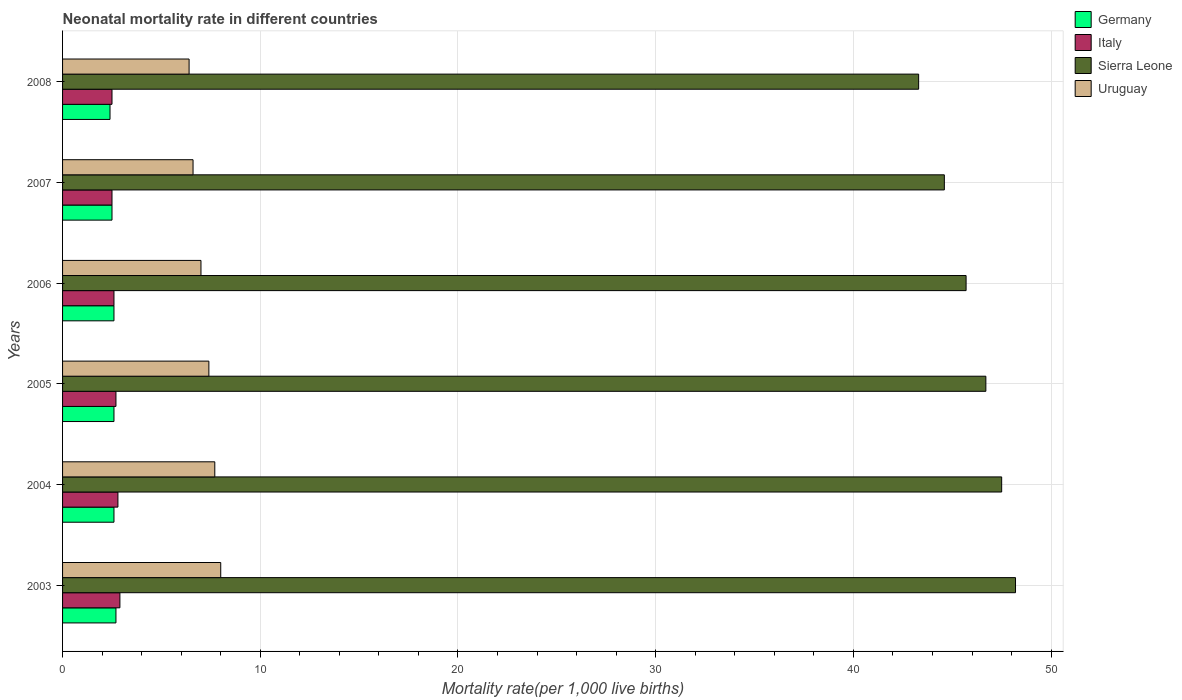How many groups of bars are there?
Your response must be concise. 6. How many bars are there on the 3rd tick from the bottom?
Provide a short and direct response. 4. What is the neonatal mortality rate in Italy in 2008?
Make the answer very short. 2.5. Across all years, what is the maximum neonatal mortality rate in Sierra Leone?
Offer a terse response. 48.2. Across all years, what is the minimum neonatal mortality rate in Uruguay?
Your response must be concise. 6.4. In which year was the neonatal mortality rate in Germany minimum?
Ensure brevity in your answer.  2008. What is the total neonatal mortality rate in Uruguay in the graph?
Your response must be concise. 43.1. What is the difference between the neonatal mortality rate in Italy in 2004 and that in 2005?
Keep it short and to the point. 0.1. What is the average neonatal mortality rate in Germany per year?
Give a very brief answer. 2.57. In the year 2007, what is the difference between the neonatal mortality rate in Germany and neonatal mortality rate in Italy?
Your answer should be very brief. 0. What is the ratio of the neonatal mortality rate in Germany in 2005 to that in 2006?
Your response must be concise. 1. What is the difference between the highest and the second highest neonatal mortality rate in Uruguay?
Make the answer very short. 0.3. What is the difference between the highest and the lowest neonatal mortality rate in Italy?
Offer a terse response. 0.4. In how many years, is the neonatal mortality rate in Sierra Leone greater than the average neonatal mortality rate in Sierra Leone taken over all years?
Provide a short and direct response. 3. What does the 4th bar from the bottom in 2003 represents?
Ensure brevity in your answer.  Uruguay. How many bars are there?
Give a very brief answer. 24. Does the graph contain grids?
Give a very brief answer. Yes. What is the title of the graph?
Offer a terse response. Neonatal mortality rate in different countries. Does "Comoros" appear as one of the legend labels in the graph?
Ensure brevity in your answer.  No. What is the label or title of the X-axis?
Your answer should be compact. Mortality rate(per 1,0 live births). What is the label or title of the Y-axis?
Your answer should be compact. Years. What is the Mortality rate(per 1,000 live births) of Sierra Leone in 2003?
Your answer should be very brief. 48.2. What is the Mortality rate(per 1,000 live births) of Uruguay in 2003?
Offer a very short reply. 8. What is the Mortality rate(per 1,000 live births) of Germany in 2004?
Make the answer very short. 2.6. What is the Mortality rate(per 1,000 live births) of Sierra Leone in 2004?
Make the answer very short. 47.5. What is the Mortality rate(per 1,000 live births) in Sierra Leone in 2005?
Ensure brevity in your answer.  46.7. What is the Mortality rate(per 1,000 live births) in Uruguay in 2005?
Offer a very short reply. 7.4. What is the Mortality rate(per 1,000 live births) of Germany in 2006?
Provide a short and direct response. 2.6. What is the Mortality rate(per 1,000 live births) of Italy in 2006?
Provide a succinct answer. 2.6. What is the Mortality rate(per 1,000 live births) of Sierra Leone in 2006?
Ensure brevity in your answer.  45.7. What is the Mortality rate(per 1,000 live births) of Italy in 2007?
Keep it short and to the point. 2.5. What is the Mortality rate(per 1,000 live births) in Sierra Leone in 2007?
Keep it short and to the point. 44.6. What is the Mortality rate(per 1,000 live births) in Uruguay in 2007?
Offer a terse response. 6.6. What is the Mortality rate(per 1,000 live births) of Germany in 2008?
Offer a very short reply. 2.4. What is the Mortality rate(per 1,000 live births) of Sierra Leone in 2008?
Provide a succinct answer. 43.3. Across all years, what is the maximum Mortality rate(per 1,000 live births) in Germany?
Keep it short and to the point. 2.7. Across all years, what is the maximum Mortality rate(per 1,000 live births) in Sierra Leone?
Your response must be concise. 48.2. Across all years, what is the minimum Mortality rate(per 1,000 live births) of Sierra Leone?
Offer a very short reply. 43.3. What is the total Mortality rate(per 1,000 live births) in Germany in the graph?
Your answer should be very brief. 15.4. What is the total Mortality rate(per 1,000 live births) of Sierra Leone in the graph?
Ensure brevity in your answer.  276. What is the total Mortality rate(per 1,000 live births) in Uruguay in the graph?
Provide a succinct answer. 43.1. What is the difference between the Mortality rate(per 1,000 live births) of Germany in 2003 and that in 2004?
Your response must be concise. 0.1. What is the difference between the Mortality rate(per 1,000 live births) of Italy in 2003 and that in 2004?
Your response must be concise. 0.1. What is the difference between the Mortality rate(per 1,000 live births) of Sierra Leone in 2003 and that in 2004?
Offer a very short reply. 0.7. What is the difference between the Mortality rate(per 1,000 live births) in Italy in 2003 and that in 2005?
Your answer should be very brief. 0.2. What is the difference between the Mortality rate(per 1,000 live births) in Uruguay in 2003 and that in 2005?
Give a very brief answer. 0.6. What is the difference between the Mortality rate(per 1,000 live births) in Germany in 2003 and that in 2006?
Offer a very short reply. 0.1. What is the difference between the Mortality rate(per 1,000 live births) of Italy in 2003 and that in 2006?
Offer a very short reply. 0.3. What is the difference between the Mortality rate(per 1,000 live births) of Sierra Leone in 2003 and that in 2006?
Offer a terse response. 2.5. What is the difference between the Mortality rate(per 1,000 live births) of Germany in 2003 and that in 2007?
Give a very brief answer. 0.2. What is the difference between the Mortality rate(per 1,000 live births) in Uruguay in 2003 and that in 2007?
Ensure brevity in your answer.  1.4. What is the difference between the Mortality rate(per 1,000 live births) in Germany in 2003 and that in 2008?
Make the answer very short. 0.3. What is the difference between the Mortality rate(per 1,000 live births) in Italy in 2003 and that in 2008?
Your answer should be compact. 0.4. What is the difference between the Mortality rate(per 1,000 live births) in Germany in 2004 and that in 2005?
Give a very brief answer. 0. What is the difference between the Mortality rate(per 1,000 live births) in Sierra Leone in 2004 and that in 2005?
Offer a very short reply. 0.8. What is the difference between the Mortality rate(per 1,000 live births) of Germany in 2004 and that in 2006?
Provide a succinct answer. 0. What is the difference between the Mortality rate(per 1,000 live births) in Uruguay in 2004 and that in 2006?
Your answer should be compact. 0.7. What is the difference between the Mortality rate(per 1,000 live births) in Sierra Leone in 2004 and that in 2007?
Ensure brevity in your answer.  2.9. What is the difference between the Mortality rate(per 1,000 live births) of Italy in 2004 and that in 2008?
Make the answer very short. 0.3. What is the difference between the Mortality rate(per 1,000 live births) in Italy in 2005 and that in 2006?
Ensure brevity in your answer.  0.1. What is the difference between the Mortality rate(per 1,000 live births) of Italy in 2005 and that in 2007?
Offer a very short reply. 0.2. What is the difference between the Mortality rate(per 1,000 live births) of Sierra Leone in 2005 and that in 2008?
Your response must be concise. 3.4. What is the difference between the Mortality rate(per 1,000 live births) in Italy in 2006 and that in 2007?
Your response must be concise. 0.1. What is the difference between the Mortality rate(per 1,000 live births) in Sierra Leone in 2006 and that in 2007?
Offer a terse response. 1.1. What is the difference between the Mortality rate(per 1,000 live births) of Germany in 2006 and that in 2008?
Keep it short and to the point. 0.2. What is the difference between the Mortality rate(per 1,000 live births) in Italy in 2006 and that in 2008?
Ensure brevity in your answer.  0.1. What is the difference between the Mortality rate(per 1,000 live births) of Uruguay in 2006 and that in 2008?
Keep it short and to the point. 0.6. What is the difference between the Mortality rate(per 1,000 live births) in Germany in 2003 and the Mortality rate(per 1,000 live births) in Italy in 2004?
Provide a succinct answer. -0.1. What is the difference between the Mortality rate(per 1,000 live births) in Germany in 2003 and the Mortality rate(per 1,000 live births) in Sierra Leone in 2004?
Offer a very short reply. -44.8. What is the difference between the Mortality rate(per 1,000 live births) of Germany in 2003 and the Mortality rate(per 1,000 live births) of Uruguay in 2004?
Make the answer very short. -5. What is the difference between the Mortality rate(per 1,000 live births) of Italy in 2003 and the Mortality rate(per 1,000 live births) of Sierra Leone in 2004?
Your answer should be compact. -44.6. What is the difference between the Mortality rate(per 1,000 live births) of Italy in 2003 and the Mortality rate(per 1,000 live births) of Uruguay in 2004?
Offer a terse response. -4.8. What is the difference between the Mortality rate(per 1,000 live births) of Sierra Leone in 2003 and the Mortality rate(per 1,000 live births) of Uruguay in 2004?
Keep it short and to the point. 40.5. What is the difference between the Mortality rate(per 1,000 live births) in Germany in 2003 and the Mortality rate(per 1,000 live births) in Italy in 2005?
Provide a succinct answer. 0. What is the difference between the Mortality rate(per 1,000 live births) of Germany in 2003 and the Mortality rate(per 1,000 live births) of Sierra Leone in 2005?
Make the answer very short. -44. What is the difference between the Mortality rate(per 1,000 live births) of Germany in 2003 and the Mortality rate(per 1,000 live births) of Uruguay in 2005?
Keep it short and to the point. -4.7. What is the difference between the Mortality rate(per 1,000 live births) of Italy in 2003 and the Mortality rate(per 1,000 live births) of Sierra Leone in 2005?
Ensure brevity in your answer.  -43.8. What is the difference between the Mortality rate(per 1,000 live births) in Italy in 2003 and the Mortality rate(per 1,000 live births) in Uruguay in 2005?
Offer a terse response. -4.5. What is the difference between the Mortality rate(per 1,000 live births) of Sierra Leone in 2003 and the Mortality rate(per 1,000 live births) of Uruguay in 2005?
Give a very brief answer. 40.8. What is the difference between the Mortality rate(per 1,000 live births) of Germany in 2003 and the Mortality rate(per 1,000 live births) of Sierra Leone in 2006?
Your response must be concise. -43. What is the difference between the Mortality rate(per 1,000 live births) of Italy in 2003 and the Mortality rate(per 1,000 live births) of Sierra Leone in 2006?
Keep it short and to the point. -42.8. What is the difference between the Mortality rate(per 1,000 live births) of Sierra Leone in 2003 and the Mortality rate(per 1,000 live births) of Uruguay in 2006?
Provide a succinct answer. 41.2. What is the difference between the Mortality rate(per 1,000 live births) in Germany in 2003 and the Mortality rate(per 1,000 live births) in Italy in 2007?
Your answer should be very brief. 0.2. What is the difference between the Mortality rate(per 1,000 live births) in Germany in 2003 and the Mortality rate(per 1,000 live births) in Sierra Leone in 2007?
Provide a succinct answer. -41.9. What is the difference between the Mortality rate(per 1,000 live births) of Germany in 2003 and the Mortality rate(per 1,000 live births) of Uruguay in 2007?
Ensure brevity in your answer.  -3.9. What is the difference between the Mortality rate(per 1,000 live births) of Italy in 2003 and the Mortality rate(per 1,000 live births) of Sierra Leone in 2007?
Provide a short and direct response. -41.7. What is the difference between the Mortality rate(per 1,000 live births) of Sierra Leone in 2003 and the Mortality rate(per 1,000 live births) of Uruguay in 2007?
Offer a terse response. 41.6. What is the difference between the Mortality rate(per 1,000 live births) in Germany in 2003 and the Mortality rate(per 1,000 live births) in Italy in 2008?
Your answer should be very brief. 0.2. What is the difference between the Mortality rate(per 1,000 live births) of Germany in 2003 and the Mortality rate(per 1,000 live births) of Sierra Leone in 2008?
Give a very brief answer. -40.6. What is the difference between the Mortality rate(per 1,000 live births) in Germany in 2003 and the Mortality rate(per 1,000 live births) in Uruguay in 2008?
Your answer should be very brief. -3.7. What is the difference between the Mortality rate(per 1,000 live births) in Italy in 2003 and the Mortality rate(per 1,000 live births) in Sierra Leone in 2008?
Offer a terse response. -40.4. What is the difference between the Mortality rate(per 1,000 live births) of Sierra Leone in 2003 and the Mortality rate(per 1,000 live births) of Uruguay in 2008?
Make the answer very short. 41.8. What is the difference between the Mortality rate(per 1,000 live births) in Germany in 2004 and the Mortality rate(per 1,000 live births) in Italy in 2005?
Provide a succinct answer. -0.1. What is the difference between the Mortality rate(per 1,000 live births) in Germany in 2004 and the Mortality rate(per 1,000 live births) in Sierra Leone in 2005?
Offer a very short reply. -44.1. What is the difference between the Mortality rate(per 1,000 live births) in Germany in 2004 and the Mortality rate(per 1,000 live births) in Uruguay in 2005?
Keep it short and to the point. -4.8. What is the difference between the Mortality rate(per 1,000 live births) in Italy in 2004 and the Mortality rate(per 1,000 live births) in Sierra Leone in 2005?
Provide a short and direct response. -43.9. What is the difference between the Mortality rate(per 1,000 live births) of Sierra Leone in 2004 and the Mortality rate(per 1,000 live births) of Uruguay in 2005?
Give a very brief answer. 40.1. What is the difference between the Mortality rate(per 1,000 live births) in Germany in 2004 and the Mortality rate(per 1,000 live births) in Sierra Leone in 2006?
Provide a short and direct response. -43.1. What is the difference between the Mortality rate(per 1,000 live births) of Germany in 2004 and the Mortality rate(per 1,000 live births) of Uruguay in 2006?
Offer a terse response. -4.4. What is the difference between the Mortality rate(per 1,000 live births) in Italy in 2004 and the Mortality rate(per 1,000 live births) in Sierra Leone in 2006?
Offer a very short reply. -42.9. What is the difference between the Mortality rate(per 1,000 live births) of Sierra Leone in 2004 and the Mortality rate(per 1,000 live births) of Uruguay in 2006?
Provide a succinct answer. 40.5. What is the difference between the Mortality rate(per 1,000 live births) of Germany in 2004 and the Mortality rate(per 1,000 live births) of Italy in 2007?
Your answer should be compact. 0.1. What is the difference between the Mortality rate(per 1,000 live births) of Germany in 2004 and the Mortality rate(per 1,000 live births) of Sierra Leone in 2007?
Keep it short and to the point. -42. What is the difference between the Mortality rate(per 1,000 live births) of Germany in 2004 and the Mortality rate(per 1,000 live births) of Uruguay in 2007?
Give a very brief answer. -4. What is the difference between the Mortality rate(per 1,000 live births) of Italy in 2004 and the Mortality rate(per 1,000 live births) of Sierra Leone in 2007?
Keep it short and to the point. -41.8. What is the difference between the Mortality rate(per 1,000 live births) of Sierra Leone in 2004 and the Mortality rate(per 1,000 live births) of Uruguay in 2007?
Your response must be concise. 40.9. What is the difference between the Mortality rate(per 1,000 live births) of Germany in 2004 and the Mortality rate(per 1,000 live births) of Italy in 2008?
Make the answer very short. 0.1. What is the difference between the Mortality rate(per 1,000 live births) of Germany in 2004 and the Mortality rate(per 1,000 live births) of Sierra Leone in 2008?
Keep it short and to the point. -40.7. What is the difference between the Mortality rate(per 1,000 live births) of Germany in 2004 and the Mortality rate(per 1,000 live births) of Uruguay in 2008?
Provide a short and direct response. -3.8. What is the difference between the Mortality rate(per 1,000 live births) in Italy in 2004 and the Mortality rate(per 1,000 live births) in Sierra Leone in 2008?
Provide a short and direct response. -40.5. What is the difference between the Mortality rate(per 1,000 live births) of Italy in 2004 and the Mortality rate(per 1,000 live births) of Uruguay in 2008?
Offer a very short reply. -3.6. What is the difference between the Mortality rate(per 1,000 live births) of Sierra Leone in 2004 and the Mortality rate(per 1,000 live births) of Uruguay in 2008?
Offer a terse response. 41.1. What is the difference between the Mortality rate(per 1,000 live births) in Germany in 2005 and the Mortality rate(per 1,000 live births) in Sierra Leone in 2006?
Provide a succinct answer. -43.1. What is the difference between the Mortality rate(per 1,000 live births) in Italy in 2005 and the Mortality rate(per 1,000 live births) in Sierra Leone in 2006?
Your response must be concise. -43. What is the difference between the Mortality rate(per 1,000 live births) in Italy in 2005 and the Mortality rate(per 1,000 live births) in Uruguay in 2006?
Keep it short and to the point. -4.3. What is the difference between the Mortality rate(per 1,000 live births) in Sierra Leone in 2005 and the Mortality rate(per 1,000 live births) in Uruguay in 2006?
Your answer should be very brief. 39.7. What is the difference between the Mortality rate(per 1,000 live births) of Germany in 2005 and the Mortality rate(per 1,000 live births) of Italy in 2007?
Give a very brief answer. 0.1. What is the difference between the Mortality rate(per 1,000 live births) of Germany in 2005 and the Mortality rate(per 1,000 live births) of Sierra Leone in 2007?
Offer a very short reply. -42. What is the difference between the Mortality rate(per 1,000 live births) in Italy in 2005 and the Mortality rate(per 1,000 live births) in Sierra Leone in 2007?
Ensure brevity in your answer.  -41.9. What is the difference between the Mortality rate(per 1,000 live births) of Sierra Leone in 2005 and the Mortality rate(per 1,000 live births) of Uruguay in 2007?
Your answer should be very brief. 40.1. What is the difference between the Mortality rate(per 1,000 live births) in Germany in 2005 and the Mortality rate(per 1,000 live births) in Italy in 2008?
Your answer should be compact. 0.1. What is the difference between the Mortality rate(per 1,000 live births) of Germany in 2005 and the Mortality rate(per 1,000 live births) of Sierra Leone in 2008?
Keep it short and to the point. -40.7. What is the difference between the Mortality rate(per 1,000 live births) of Germany in 2005 and the Mortality rate(per 1,000 live births) of Uruguay in 2008?
Keep it short and to the point. -3.8. What is the difference between the Mortality rate(per 1,000 live births) in Italy in 2005 and the Mortality rate(per 1,000 live births) in Sierra Leone in 2008?
Your answer should be very brief. -40.6. What is the difference between the Mortality rate(per 1,000 live births) in Italy in 2005 and the Mortality rate(per 1,000 live births) in Uruguay in 2008?
Offer a very short reply. -3.7. What is the difference between the Mortality rate(per 1,000 live births) of Sierra Leone in 2005 and the Mortality rate(per 1,000 live births) of Uruguay in 2008?
Offer a very short reply. 40.3. What is the difference between the Mortality rate(per 1,000 live births) of Germany in 2006 and the Mortality rate(per 1,000 live births) of Sierra Leone in 2007?
Give a very brief answer. -42. What is the difference between the Mortality rate(per 1,000 live births) of Germany in 2006 and the Mortality rate(per 1,000 live births) of Uruguay in 2007?
Give a very brief answer. -4. What is the difference between the Mortality rate(per 1,000 live births) in Italy in 2006 and the Mortality rate(per 1,000 live births) in Sierra Leone in 2007?
Ensure brevity in your answer.  -42. What is the difference between the Mortality rate(per 1,000 live births) in Italy in 2006 and the Mortality rate(per 1,000 live births) in Uruguay in 2007?
Provide a succinct answer. -4. What is the difference between the Mortality rate(per 1,000 live births) of Sierra Leone in 2006 and the Mortality rate(per 1,000 live births) of Uruguay in 2007?
Your answer should be compact. 39.1. What is the difference between the Mortality rate(per 1,000 live births) in Germany in 2006 and the Mortality rate(per 1,000 live births) in Sierra Leone in 2008?
Your response must be concise. -40.7. What is the difference between the Mortality rate(per 1,000 live births) of Italy in 2006 and the Mortality rate(per 1,000 live births) of Sierra Leone in 2008?
Ensure brevity in your answer.  -40.7. What is the difference between the Mortality rate(per 1,000 live births) in Sierra Leone in 2006 and the Mortality rate(per 1,000 live births) in Uruguay in 2008?
Your answer should be very brief. 39.3. What is the difference between the Mortality rate(per 1,000 live births) in Germany in 2007 and the Mortality rate(per 1,000 live births) in Sierra Leone in 2008?
Provide a short and direct response. -40.8. What is the difference between the Mortality rate(per 1,000 live births) of Germany in 2007 and the Mortality rate(per 1,000 live births) of Uruguay in 2008?
Offer a terse response. -3.9. What is the difference between the Mortality rate(per 1,000 live births) in Italy in 2007 and the Mortality rate(per 1,000 live births) in Sierra Leone in 2008?
Offer a very short reply. -40.8. What is the difference between the Mortality rate(per 1,000 live births) in Sierra Leone in 2007 and the Mortality rate(per 1,000 live births) in Uruguay in 2008?
Offer a very short reply. 38.2. What is the average Mortality rate(per 1,000 live births) in Germany per year?
Provide a short and direct response. 2.57. What is the average Mortality rate(per 1,000 live births) in Italy per year?
Your response must be concise. 2.67. What is the average Mortality rate(per 1,000 live births) of Uruguay per year?
Keep it short and to the point. 7.18. In the year 2003, what is the difference between the Mortality rate(per 1,000 live births) of Germany and Mortality rate(per 1,000 live births) of Sierra Leone?
Your response must be concise. -45.5. In the year 2003, what is the difference between the Mortality rate(per 1,000 live births) in Italy and Mortality rate(per 1,000 live births) in Sierra Leone?
Ensure brevity in your answer.  -45.3. In the year 2003, what is the difference between the Mortality rate(per 1,000 live births) in Italy and Mortality rate(per 1,000 live births) in Uruguay?
Your answer should be very brief. -5.1. In the year 2003, what is the difference between the Mortality rate(per 1,000 live births) of Sierra Leone and Mortality rate(per 1,000 live births) of Uruguay?
Your answer should be compact. 40.2. In the year 2004, what is the difference between the Mortality rate(per 1,000 live births) of Germany and Mortality rate(per 1,000 live births) of Italy?
Your answer should be compact. -0.2. In the year 2004, what is the difference between the Mortality rate(per 1,000 live births) of Germany and Mortality rate(per 1,000 live births) of Sierra Leone?
Provide a short and direct response. -44.9. In the year 2004, what is the difference between the Mortality rate(per 1,000 live births) in Germany and Mortality rate(per 1,000 live births) in Uruguay?
Offer a very short reply. -5.1. In the year 2004, what is the difference between the Mortality rate(per 1,000 live births) in Italy and Mortality rate(per 1,000 live births) in Sierra Leone?
Provide a succinct answer. -44.7. In the year 2004, what is the difference between the Mortality rate(per 1,000 live births) of Sierra Leone and Mortality rate(per 1,000 live births) of Uruguay?
Your response must be concise. 39.8. In the year 2005, what is the difference between the Mortality rate(per 1,000 live births) in Germany and Mortality rate(per 1,000 live births) in Italy?
Your answer should be very brief. -0.1. In the year 2005, what is the difference between the Mortality rate(per 1,000 live births) of Germany and Mortality rate(per 1,000 live births) of Sierra Leone?
Make the answer very short. -44.1. In the year 2005, what is the difference between the Mortality rate(per 1,000 live births) of Italy and Mortality rate(per 1,000 live births) of Sierra Leone?
Offer a terse response. -44. In the year 2005, what is the difference between the Mortality rate(per 1,000 live births) of Sierra Leone and Mortality rate(per 1,000 live births) of Uruguay?
Your answer should be very brief. 39.3. In the year 2006, what is the difference between the Mortality rate(per 1,000 live births) of Germany and Mortality rate(per 1,000 live births) of Sierra Leone?
Provide a succinct answer. -43.1. In the year 2006, what is the difference between the Mortality rate(per 1,000 live births) of Italy and Mortality rate(per 1,000 live births) of Sierra Leone?
Your answer should be very brief. -43.1. In the year 2006, what is the difference between the Mortality rate(per 1,000 live births) of Sierra Leone and Mortality rate(per 1,000 live births) of Uruguay?
Provide a short and direct response. 38.7. In the year 2007, what is the difference between the Mortality rate(per 1,000 live births) in Germany and Mortality rate(per 1,000 live births) in Italy?
Ensure brevity in your answer.  0. In the year 2007, what is the difference between the Mortality rate(per 1,000 live births) of Germany and Mortality rate(per 1,000 live births) of Sierra Leone?
Make the answer very short. -42.1. In the year 2007, what is the difference between the Mortality rate(per 1,000 live births) of Italy and Mortality rate(per 1,000 live births) of Sierra Leone?
Keep it short and to the point. -42.1. In the year 2007, what is the difference between the Mortality rate(per 1,000 live births) in Italy and Mortality rate(per 1,000 live births) in Uruguay?
Offer a very short reply. -4.1. In the year 2008, what is the difference between the Mortality rate(per 1,000 live births) of Germany and Mortality rate(per 1,000 live births) of Sierra Leone?
Make the answer very short. -40.9. In the year 2008, what is the difference between the Mortality rate(per 1,000 live births) in Italy and Mortality rate(per 1,000 live births) in Sierra Leone?
Offer a very short reply. -40.8. In the year 2008, what is the difference between the Mortality rate(per 1,000 live births) of Sierra Leone and Mortality rate(per 1,000 live births) of Uruguay?
Offer a terse response. 36.9. What is the ratio of the Mortality rate(per 1,000 live births) in Italy in 2003 to that in 2004?
Ensure brevity in your answer.  1.04. What is the ratio of the Mortality rate(per 1,000 live births) of Sierra Leone in 2003 to that in 2004?
Make the answer very short. 1.01. What is the ratio of the Mortality rate(per 1,000 live births) in Uruguay in 2003 to that in 2004?
Offer a very short reply. 1.04. What is the ratio of the Mortality rate(per 1,000 live births) of Germany in 2003 to that in 2005?
Keep it short and to the point. 1.04. What is the ratio of the Mortality rate(per 1,000 live births) in Italy in 2003 to that in 2005?
Ensure brevity in your answer.  1.07. What is the ratio of the Mortality rate(per 1,000 live births) in Sierra Leone in 2003 to that in 2005?
Offer a terse response. 1.03. What is the ratio of the Mortality rate(per 1,000 live births) in Uruguay in 2003 to that in 2005?
Ensure brevity in your answer.  1.08. What is the ratio of the Mortality rate(per 1,000 live births) in Italy in 2003 to that in 2006?
Offer a very short reply. 1.12. What is the ratio of the Mortality rate(per 1,000 live births) in Sierra Leone in 2003 to that in 2006?
Offer a terse response. 1.05. What is the ratio of the Mortality rate(per 1,000 live births) in Germany in 2003 to that in 2007?
Keep it short and to the point. 1.08. What is the ratio of the Mortality rate(per 1,000 live births) in Italy in 2003 to that in 2007?
Ensure brevity in your answer.  1.16. What is the ratio of the Mortality rate(per 1,000 live births) of Sierra Leone in 2003 to that in 2007?
Your answer should be very brief. 1.08. What is the ratio of the Mortality rate(per 1,000 live births) of Uruguay in 2003 to that in 2007?
Provide a succinct answer. 1.21. What is the ratio of the Mortality rate(per 1,000 live births) of Italy in 2003 to that in 2008?
Your answer should be compact. 1.16. What is the ratio of the Mortality rate(per 1,000 live births) of Sierra Leone in 2003 to that in 2008?
Offer a very short reply. 1.11. What is the ratio of the Mortality rate(per 1,000 live births) of Uruguay in 2003 to that in 2008?
Offer a very short reply. 1.25. What is the ratio of the Mortality rate(per 1,000 live births) of Sierra Leone in 2004 to that in 2005?
Provide a succinct answer. 1.02. What is the ratio of the Mortality rate(per 1,000 live births) in Uruguay in 2004 to that in 2005?
Keep it short and to the point. 1.04. What is the ratio of the Mortality rate(per 1,000 live births) in Germany in 2004 to that in 2006?
Make the answer very short. 1. What is the ratio of the Mortality rate(per 1,000 live births) in Sierra Leone in 2004 to that in 2006?
Offer a very short reply. 1.04. What is the ratio of the Mortality rate(per 1,000 live births) of Italy in 2004 to that in 2007?
Provide a short and direct response. 1.12. What is the ratio of the Mortality rate(per 1,000 live births) of Sierra Leone in 2004 to that in 2007?
Make the answer very short. 1.06. What is the ratio of the Mortality rate(per 1,000 live births) in Uruguay in 2004 to that in 2007?
Your response must be concise. 1.17. What is the ratio of the Mortality rate(per 1,000 live births) in Germany in 2004 to that in 2008?
Ensure brevity in your answer.  1.08. What is the ratio of the Mortality rate(per 1,000 live births) in Italy in 2004 to that in 2008?
Offer a terse response. 1.12. What is the ratio of the Mortality rate(per 1,000 live births) in Sierra Leone in 2004 to that in 2008?
Your response must be concise. 1.1. What is the ratio of the Mortality rate(per 1,000 live births) of Uruguay in 2004 to that in 2008?
Ensure brevity in your answer.  1.2. What is the ratio of the Mortality rate(per 1,000 live births) of Sierra Leone in 2005 to that in 2006?
Keep it short and to the point. 1.02. What is the ratio of the Mortality rate(per 1,000 live births) of Uruguay in 2005 to that in 2006?
Your answer should be compact. 1.06. What is the ratio of the Mortality rate(per 1,000 live births) of Sierra Leone in 2005 to that in 2007?
Make the answer very short. 1.05. What is the ratio of the Mortality rate(per 1,000 live births) in Uruguay in 2005 to that in 2007?
Ensure brevity in your answer.  1.12. What is the ratio of the Mortality rate(per 1,000 live births) of Germany in 2005 to that in 2008?
Make the answer very short. 1.08. What is the ratio of the Mortality rate(per 1,000 live births) in Italy in 2005 to that in 2008?
Make the answer very short. 1.08. What is the ratio of the Mortality rate(per 1,000 live births) of Sierra Leone in 2005 to that in 2008?
Offer a very short reply. 1.08. What is the ratio of the Mortality rate(per 1,000 live births) of Uruguay in 2005 to that in 2008?
Provide a short and direct response. 1.16. What is the ratio of the Mortality rate(per 1,000 live births) of Sierra Leone in 2006 to that in 2007?
Provide a succinct answer. 1.02. What is the ratio of the Mortality rate(per 1,000 live births) of Uruguay in 2006 to that in 2007?
Provide a short and direct response. 1.06. What is the ratio of the Mortality rate(per 1,000 live births) in Sierra Leone in 2006 to that in 2008?
Make the answer very short. 1.06. What is the ratio of the Mortality rate(per 1,000 live births) in Uruguay in 2006 to that in 2008?
Ensure brevity in your answer.  1.09. What is the ratio of the Mortality rate(per 1,000 live births) in Germany in 2007 to that in 2008?
Give a very brief answer. 1.04. What is the ratio of the Mortality rate(per 1,000 live births) of Italy in 2007 to that in 2008?
Provide a succinct answer. 1. What is the ratio of the Mortality rate(per 1,000 live births) of Uruguay in 2007 to that in 2008?
Provide a short and direct response. 1.03. What is the difference between the highest and the second highest Mortality rate(per 1,000 live births) in Italy?
Provide a short and direct response. 0.1. What is the difference between the highest and the second highest Mortality rate(per 1,000 live births) in Sierra Leone?
Provide a succinct answer. 0.7. What is the difference between the highest and the lowest Mortality rate(per 1,000 live births) in Germany?
Offer a terse response. 0.3. What is the difference between the highest and the lowest Mortality rate(per 1,000 live births) of Uruguay?
Offer a very short reply. 1.6. 